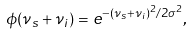Convert formula to latex. <formula><loc_0><loc_0><loc_500><loc_500>\phi ( \nu _ { s } + \nu _ { i } ) = e ^ { - ( \nu _ { s } + \nu _ { i } ) ^ { 2 } / 2 \sigma ^ { 2 } } ,</formula> 